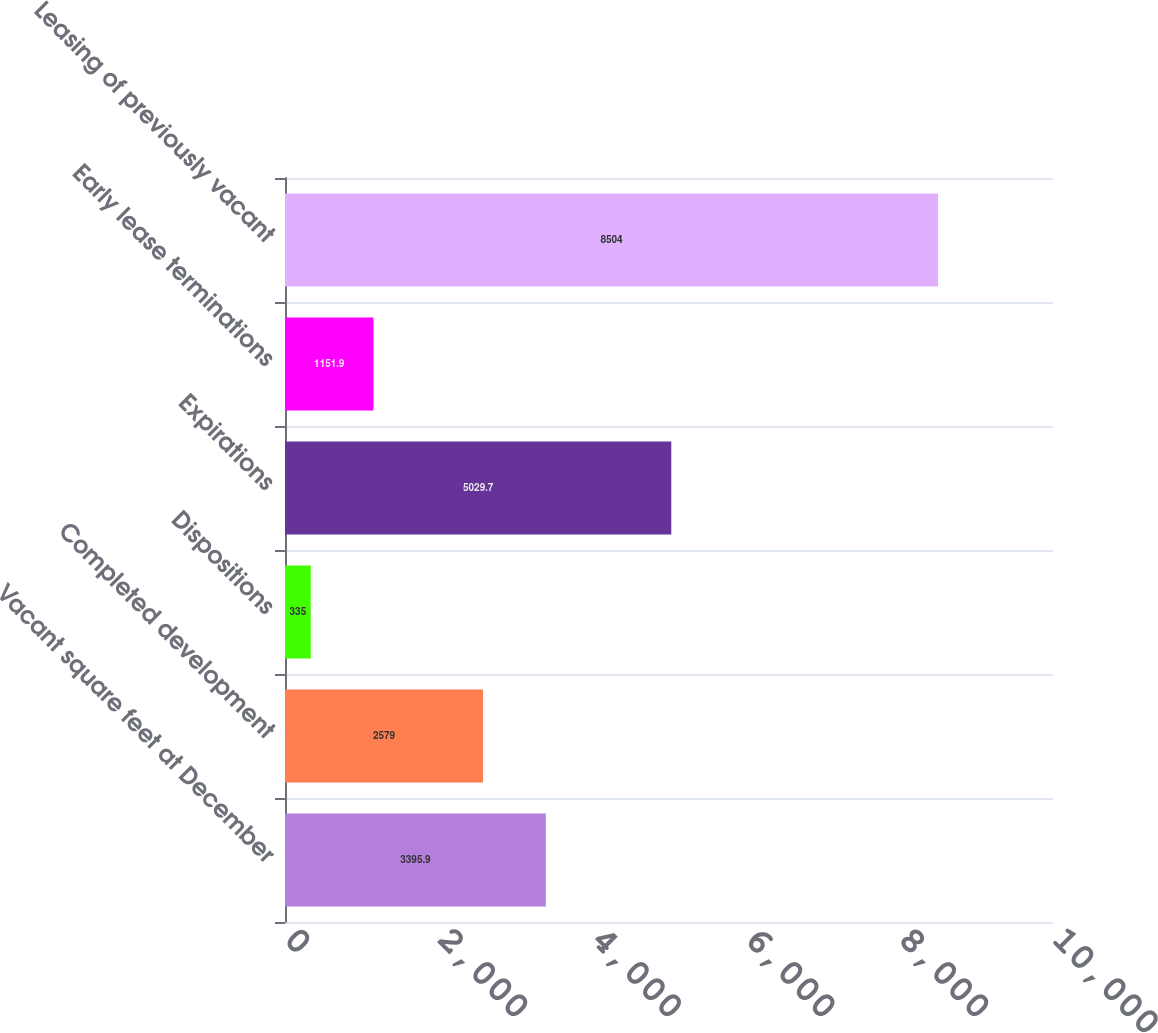<chart> <loc_0><loc_0><loc_500><loc_500><bar_chart><fcel>Vacant square feet at December<fcel>Completed development<fcel>Dispositions<fcel>Expirations<fcel>Early lease terminations<fcel>Leasing of previously vacant<nl><fcel>3395.9<fcel>2579<fcel>335<fcel>5029.7<fcel>1151.9<fcel>8504<nl></chart> 